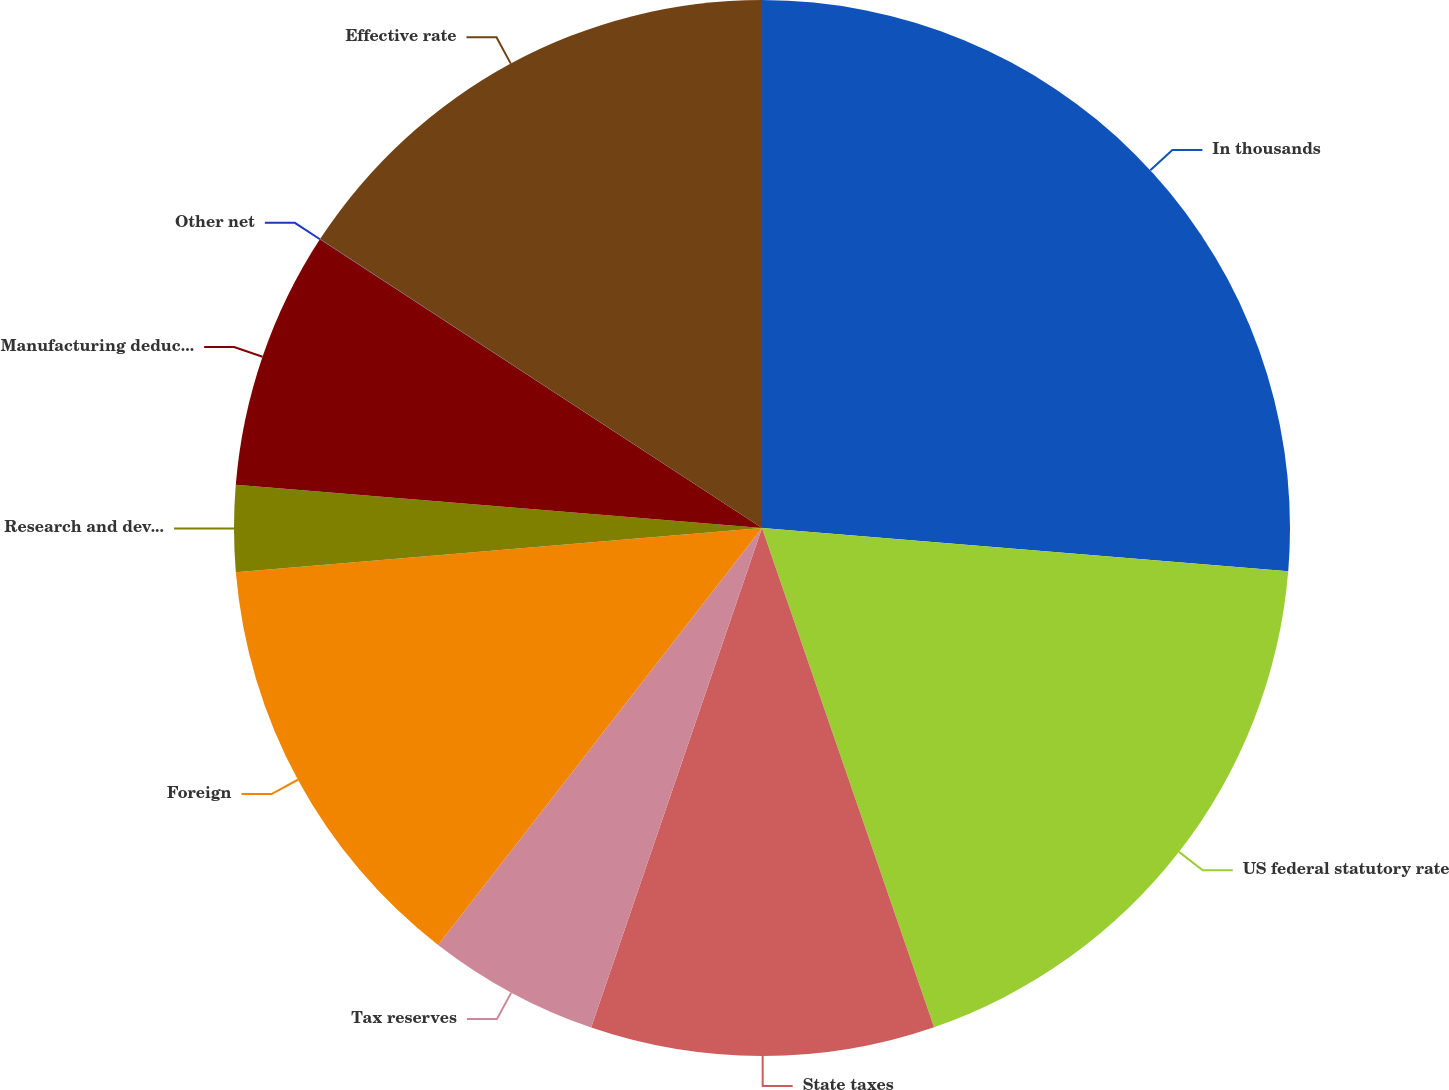Convert chart. <chart><loc_0><loc_0><loc_500><loc_500><pie_chart><fcel>In thousands<fcel>US federal statutory rate<fcel>State taxes<fcel>Tax reserves<fcel>Foreign<fcel>Research and development<fcel>Manufacturing deduction<fcel>Other net<fcel>Effective rate<nl><fcel>26.31%<fcel>18.42%<fcel>10.53%<fcel>5.27%<fcel>13.16%<fcel>2.64%<fcel>7.9%<fcel>0.01%<fcel>15.79%<nl></chart> 